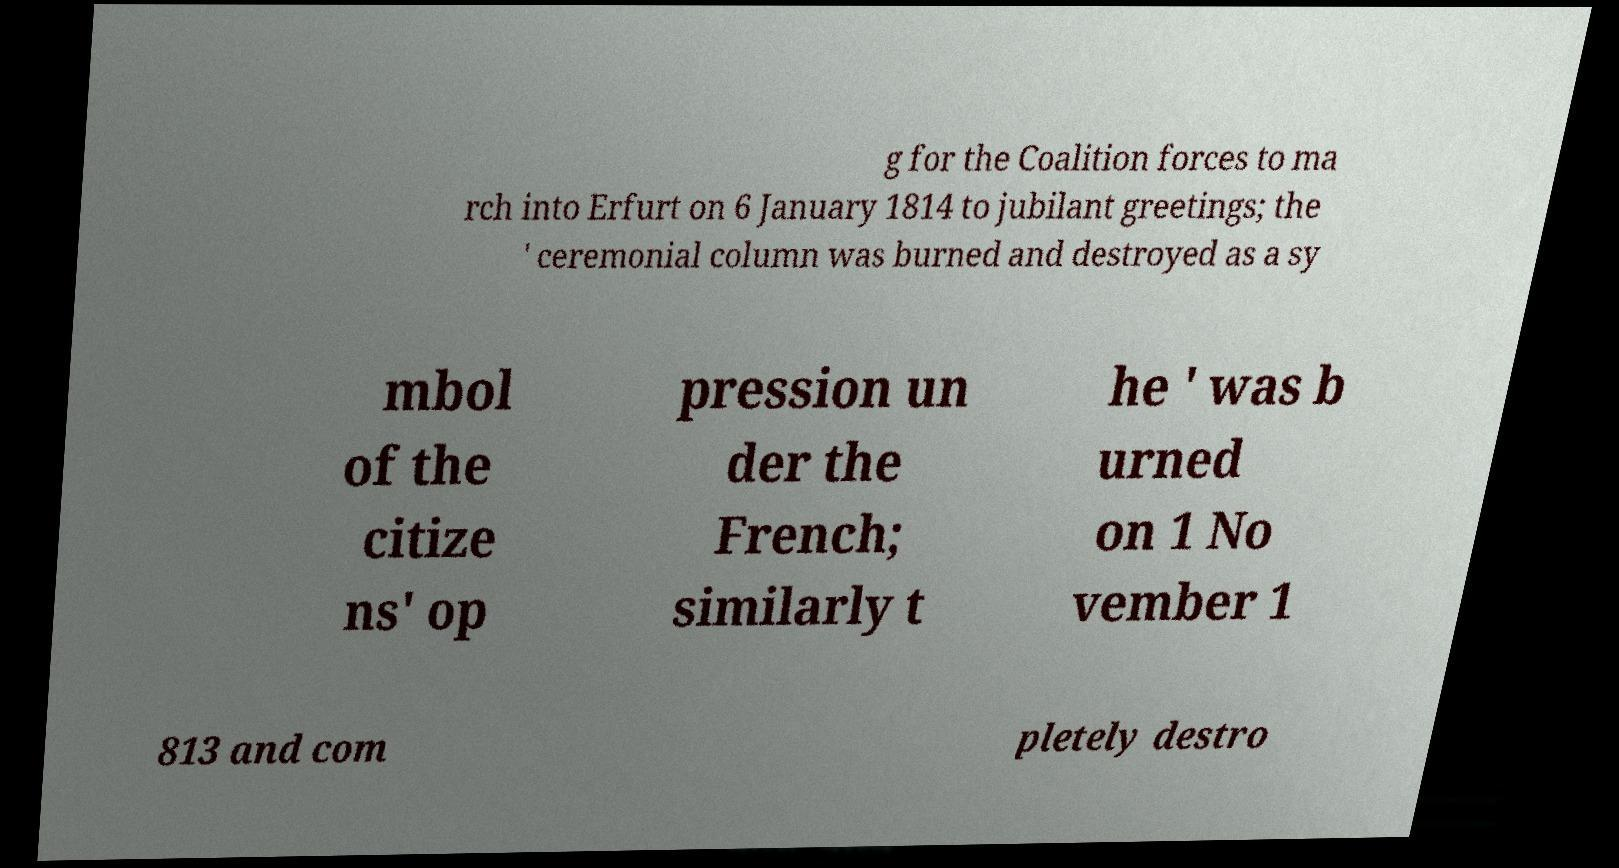Can you read and provide the text displayed in the image?This photo seems to have some interesting text. Can you extract and type it out for me? g for the Coalition forces to ma rch into Erfurt on 6 January 1814 to jubilant greetings; the ' ceremonial column was burned and destroyed as a sy mbol of the citize ns' op pression un der the French; similarly t he ' was b urned on 1 No vember 1 813 and com pletely destro 